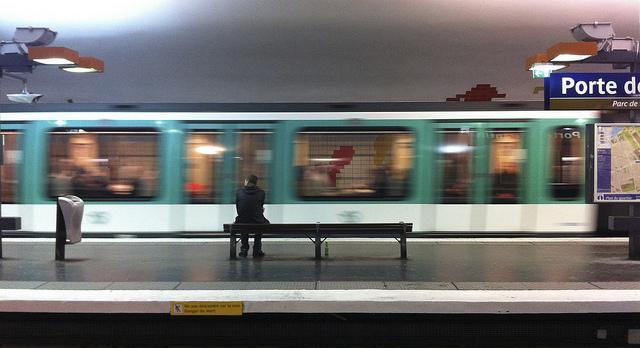How many people are on the bench?
Give a very brief answer. 1. How many trains are there?
Give a very brief answer. 1. How many benches are in the picture?
Give a very brief answer. 1. How many dump trucks are there?
Give a very brief answer. 0. 